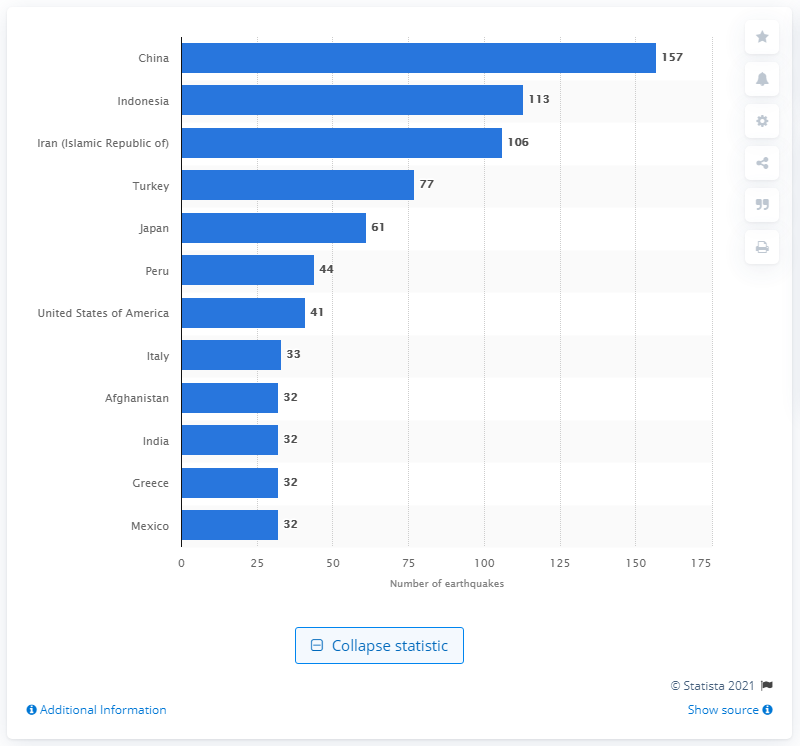Highlight a few significant elements in this photo. China reported a total of 157 earthquakes between 1900 and 2016. China had the highest number of earthquakes from 1900 to 2016. 